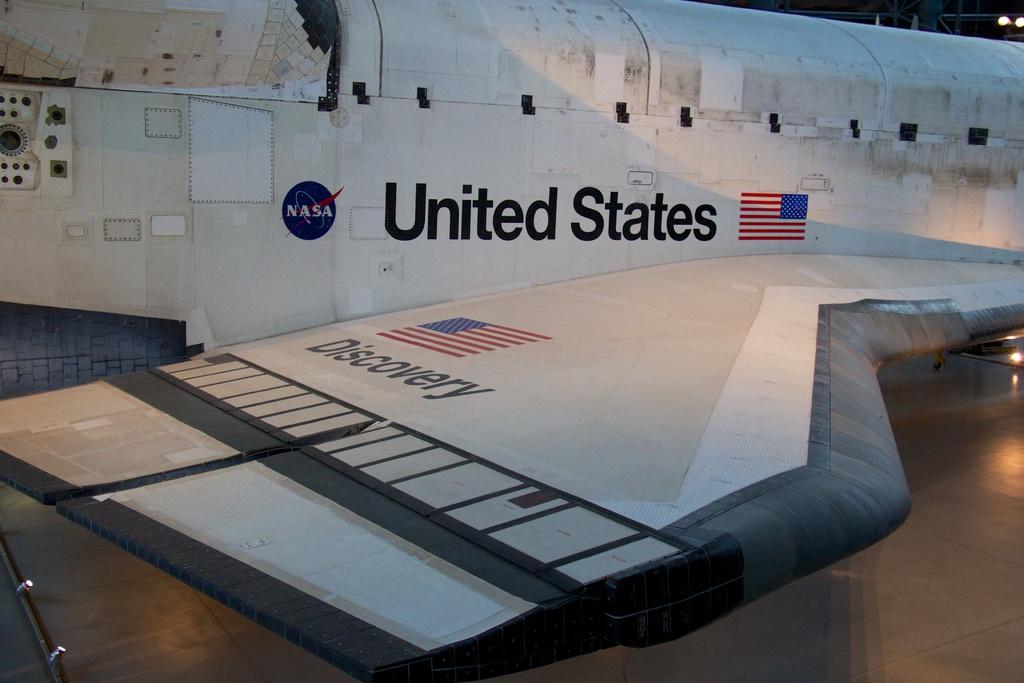What country is on the vehicle?
Keep it short and to the point. United states. What name does it say under the flag?
Keep it short and to the point. Discovery. 